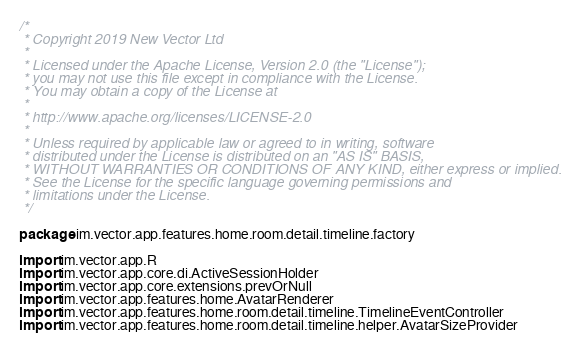<code> <loc_0><loc_0><loc_500><loc_500><_Kotlin_>/*
 * Copyright 2019 New Vector Ltd
 *
 * Licensed under the Apache License, Version 2.0 (the "License");
 * you may not use this file except in compliance with the License.
 * You may obtain a copy of the License at
 *
 * http://www.apache.org/licenses/LICENSE-2.0
 *
 * Unless required by applicable law or agreed to in writing, software
 * distributed under the License is distributed on an "AS IS" BASIS,
 * WITHOUT WARRANTIES OR CONDITIONS OF ANY KIND, either express or implied.
 * See the License for the specific language governing permissions and
 * limitations under the License.
 */

package im.vector.app.features.home.room.detail.timeline.factory

import im.vector.app.R
import im.vector.app.core.di.ActiveSessionHolder
import im.vector.app.core.extensions.prevOrNull
import im.vector.app.features.home.AvatarRenderer
import im.vector.app.features.home.room.detail.timeline.TimelineEventController
import im.vector.app.features.home.room.detail.timeline.helper.AvatarSizeProvider</code> 